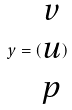Convert formula to latex. <formula><loc_0><loc_0><loc_500><loc_500>y = ( \begin{matrix} v \\ u \\ p \end{matrix} )</formula> 